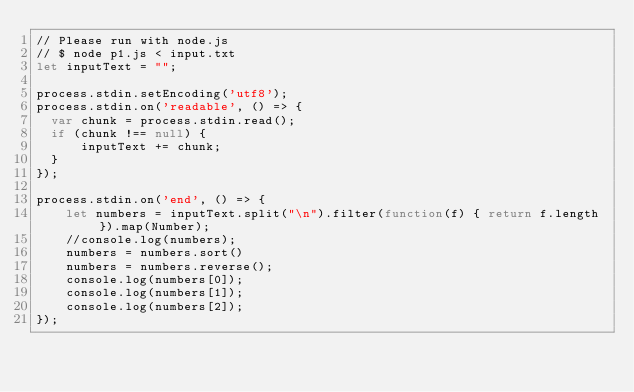<code> <loc_0><loc_0><loc_500><loc_500><_JavaScript_>// Please run with node.js
// $ node p1.js < input.txt
let inputText = "";

process.stdin.setEncoding('utf8');
process.stdin.on('readable', () => {
  var chunk = process.stdin.read();
  if (chunk !== null) {
      inputText += chunk;
  }
});

process.stdin.on('end', () => {
    let numbers = inputText.split("\n").filter(function(f) { return f.length }).map(Number);
    //console.log(numbers);
    numbers = numbers.sort()
    numbers = numbers.reverse();
    console.log(numbers[0]);
    console.log(numbers[1]);
    console.log(numbers[2]);
});</code> 